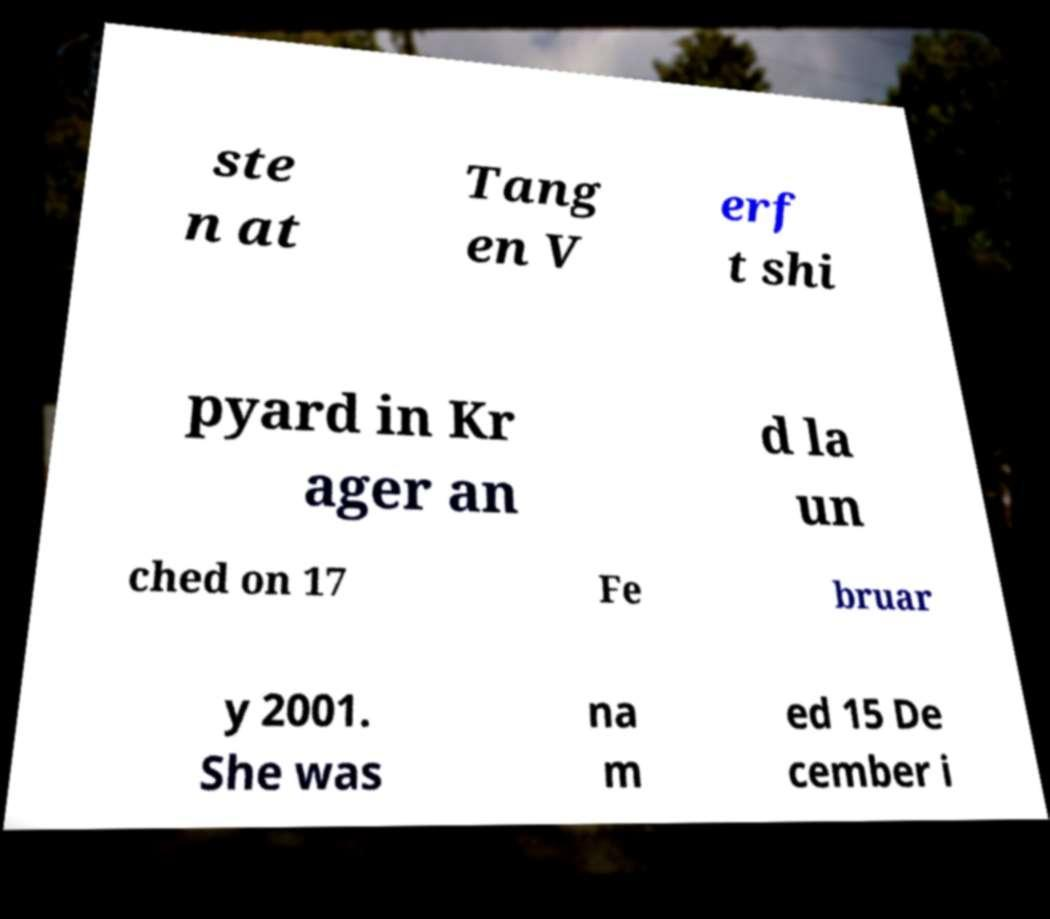Please read and relay the text visible in this image. What does it say? ste n at Tang en V erf t shi pyard in Kr ager an d la un ched on 17 Fe bruar y 2001. She was na m ed 15 De cember i 